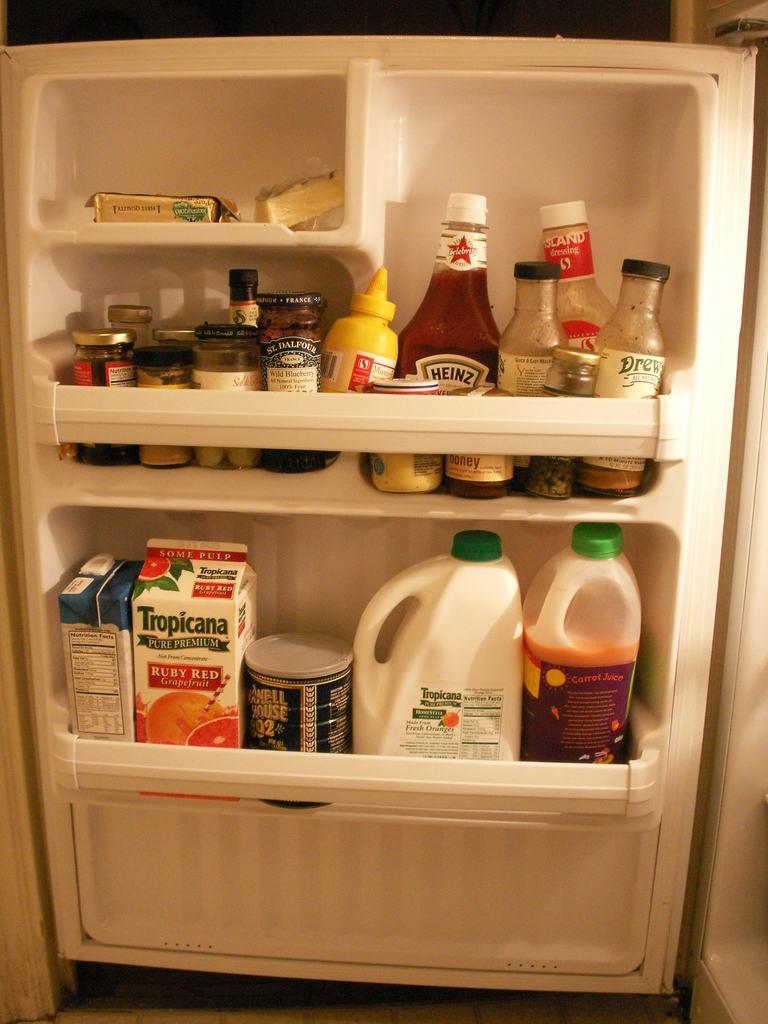<image>
Describe the image concisely. an open fridge with a tropicana carton in the door of it 